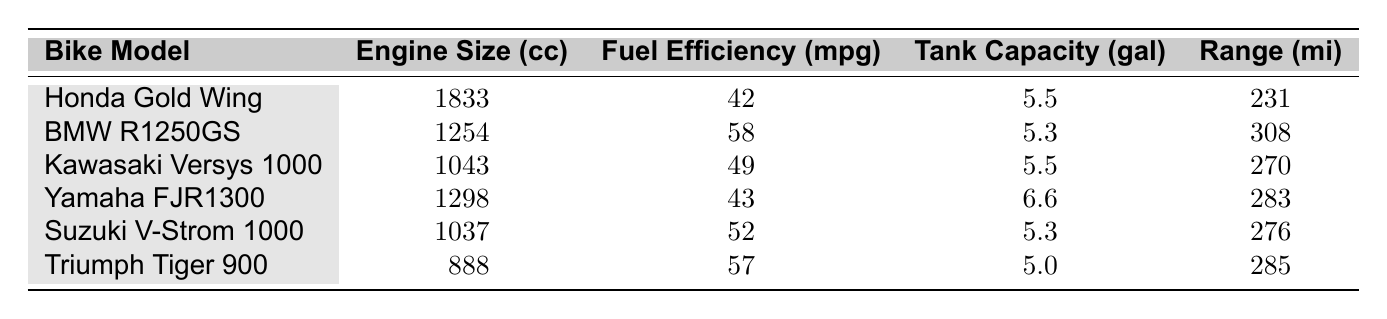What is the fuel efficiency of the BMW R1250GS? The table lists the fuel efficiency of the BMW R1250GS as 58 mpg. This is a direct lookup in the corresponding row for this bike model.
Answer: 58 mpg What is the range of the Honda Gold Wing? The range of the Honda Gold Wing is given as 231 miles in the table. This information is found in the row corresponding to the Honda Gold Wing.
Answer: 231 miles Which bike has the highest fuel efficiency? To find the highest fuel efficiency, I look at the fuel efficiency values in the table. The BMW R1250GS has the highest value at 58 mpg.
Answer: BMW R1250GS What is the average engine size of the bikes listed? The engine sizes are 1833, 1254, 1043, 1298, 1037, and 888 cc. First, I add all these values together: 1833 + 1254 + 1043 + 1298 + 1037 + 888 = 6353 cc. Then, I divide the total by the number of models (6): 6353 / 6 = 1058.83 cc.
Answer: 1058.83 cc Does the Triumph Tiger 900 have a higher fuel efficiency than the Yamaha FJR1300? The table shows the fuel efficiency of Triumph Tiger 900 as 57 mpg and the Yamaha FJR1300 as 43 mpg. Since 57 is greater than 43, the answer is yes.
Answer: Yes What is the difference in range between the BMW R1250GS and the Kawasaki Versys 1000? The range of the BMW R1250GS is 308 miles and that of the Kawasaki Versys 1000 is 270 miles. To find the difference, I subtract these two values: 308 - 270 = 38 miles.
Answer: 38 miles Which bike has the largest fuel tank capacity? I review the tank capacities: 5.5, 5.3, 5.5, 6.6, 5.3, and 5.0 gallons. The largest value is 6.6 gallons for the Yamaha FJR1300.
Answer: Yamaha FJR1300 Is the fuel efficiency of the Suzuki V-Strom 1000 greater than 50 mpg? The table states the fuel efficiency of the Suzuki V-Strom 1000 is 52 mpg, which is greater than 50. Therefore, the answer is yes.
Answer: Yes What is the total range for all the bikes listed? The individual ranges are 231, 308, 270, 283, 276, and 285 miles. Adding all together gives: 231 + 308 + 270 + 283 + 276 + 285 = 1653 miles.
Answer: 1653 miles 